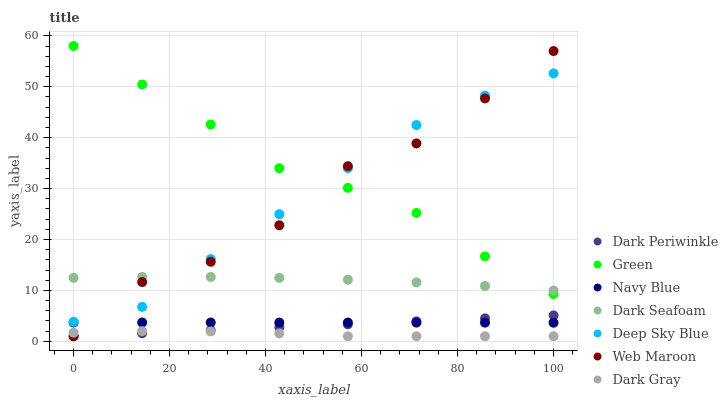Does Dark Gray have the minimum area under the curve?
Answer yes or no. Yes. Does Green have the maximum area under the curve?
Answer yes or no. Yes. Does Web Maroon have the minimum area under the curve?
Answer yes or no. No. Does Web Maroon have the maximum area under the curve?
Answer yes or no. No. Is Dark Periwinkle the smoothest?
Answer yes or no. Yes. Is Web Maroon the roughest?
Answer yes or no. Yes. Is Dark Gray the smoothest?
Answer yes or no. No. Is Dark Gray the roughest?
Answer yes or no. No. Does Web Maroon have the lowest value?
Answer yes or no. Yes. Does Dark Seafoam have the lowest value?
Answer yes or no. No. Does Green have the highest value?
Answer yes or no. Yes. Does Web Maroon have the highest value?
Answer yes or no. No. Is Dark Gray less than Green?
Answer yes or no. Yes. Is Green greater than Dark Periwinkle?
Answer yes or no. Yes. Does Web Maroon intersect Navy Blue?
Answer yes or no. Yes. Is Web Maroon less than Navy Blue?
Answer yes or no. No. Is Web Maroon greater than Navy Blue?
Answer yes or no. No. Does Dark Gray intersect Green?
Answer yes or no. No. 